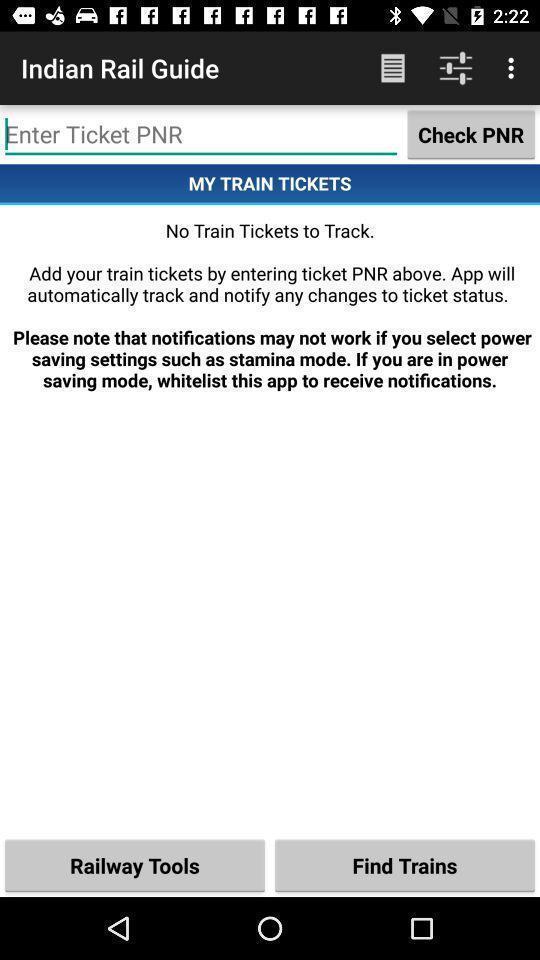Provide a textual representation of this image. Search bar to find status in a travelling app. 